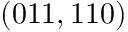<formula> <loc_0><loc_0><loc_500><loc_500>( 0 1 1 , 1 1 0 )</formula> 